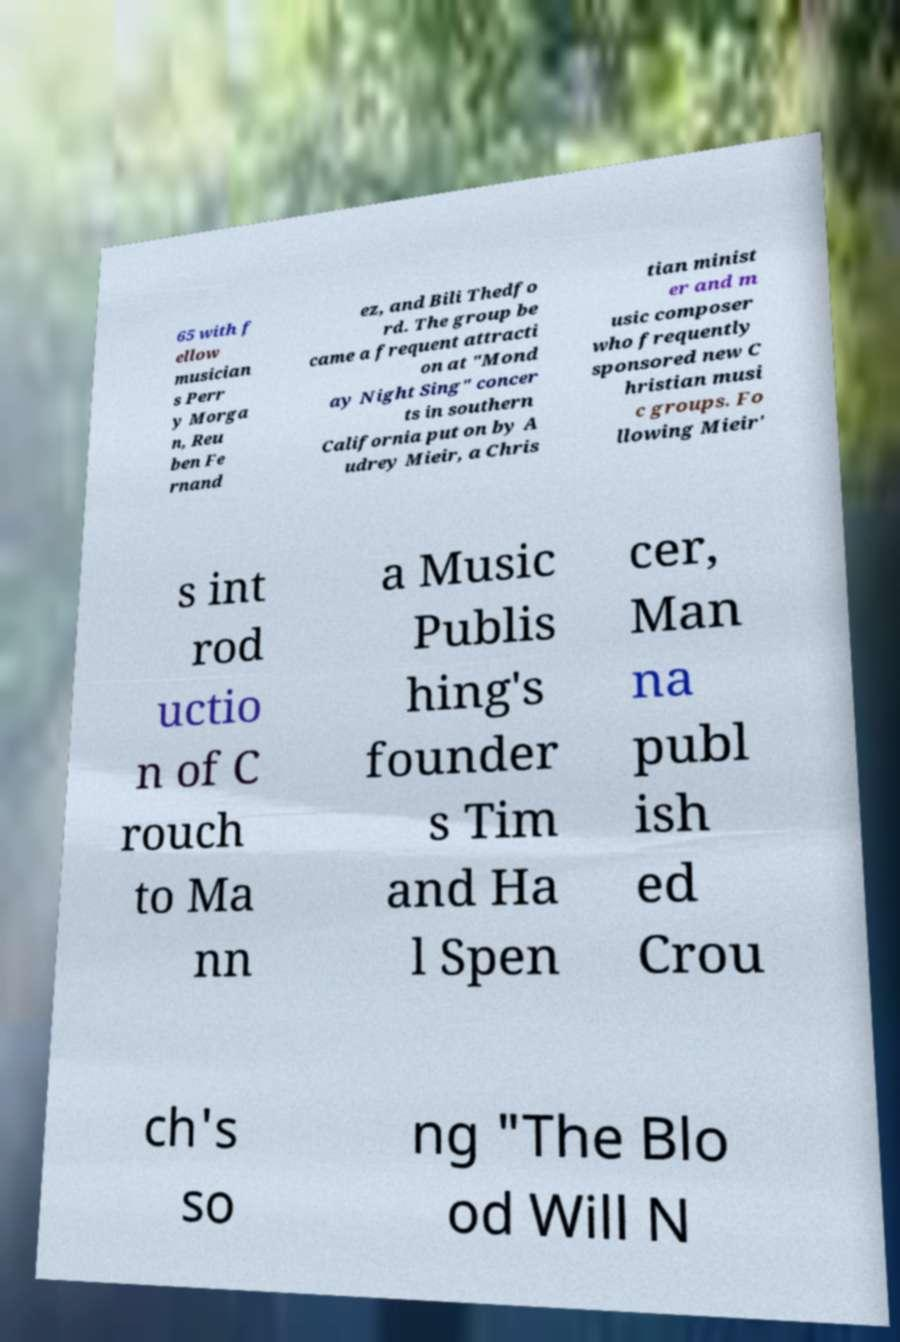Please identify and transcribe the text found in this image. 65 with f ellow musician s Perr y Morga n, Reu ben Fe rnand ez, and Bili Thedfo rd. The group be came a frequent attracti on at "Mond ay Night Sing" concer ts in southern California put on by A udrey Mieir, a Chris tian minist er and m usic composer who frequently sponsored new C hristian musi c groups. Fo llowing Mieir' s int rod uctio n of C rouch to Ma nn a Music Publis hing's founder s Tim and Ha l Spen cer, Man na publ ish ed Crou ch's so ng "The Blo od Will N 